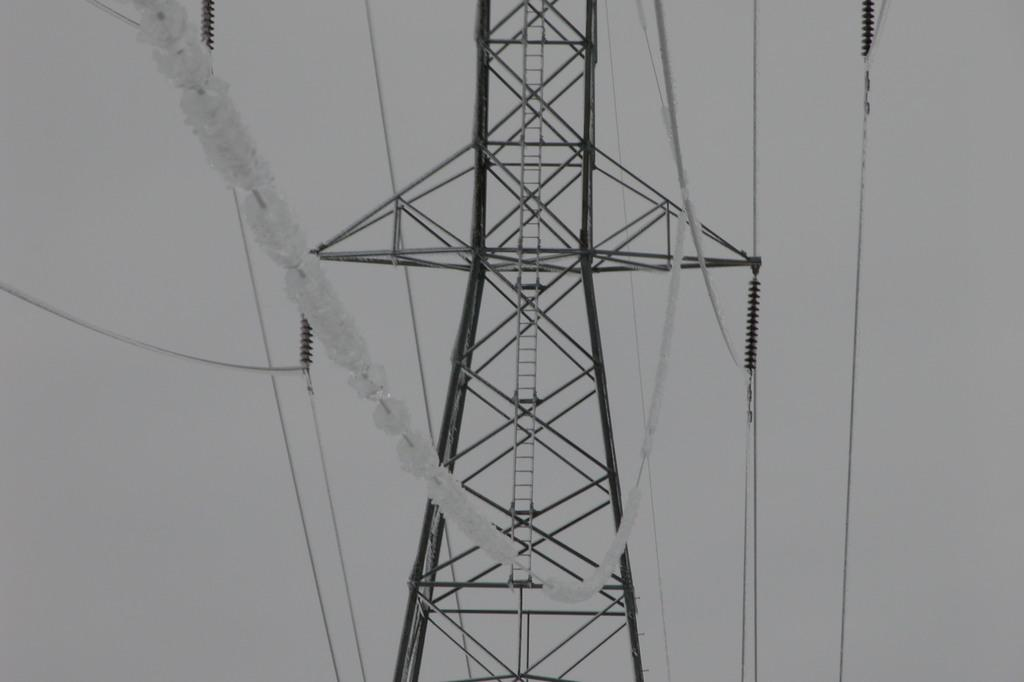What type of structure is in the image? There is an electric steel tower in the image. What is connected to the tower? Wires are connected to the tower. What can be seen in the sky on the right side of the image? The sky and clouds are visible on the right side of the image. Is there any equipment for climbing the tower? Yes, there is a ladder on the tower. Where is the notebook being used in the image? There is no notebook present in the image. How many ducks are swimming in the water near the tower? There is no water or ducks present in the image; it features an electric steel tower with wires and a ladder. 